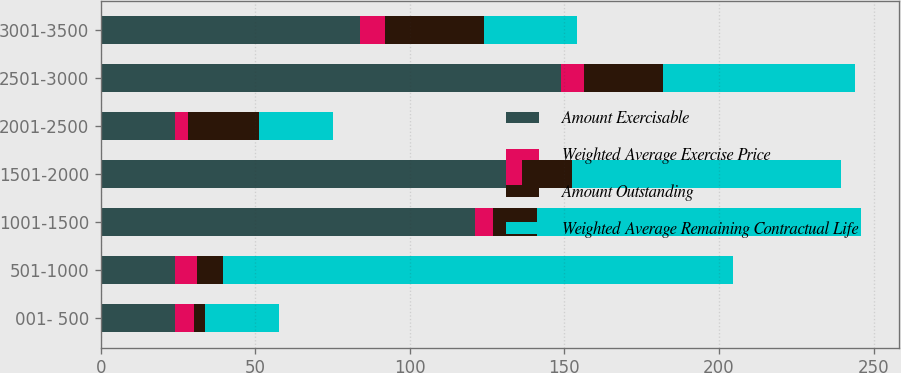Convert chart. <chart><loc_0><loc_0><loc_500><loc_500><stacked_bar_chart><ecel><fcel>001- 500<fcel>501-1000<fcel>1001-1500<fcel>1501-2000<fcel>2001-2500<fcel>2501-3000<fcel>3001-3500<nl><fcel>Amount Exercisable<fcel>24<fcel>24<fcel>121<fcel>131<fcel>24<fcel>149<fcel>84<nl><fcel>Weighted Average Exercise Price<fcel>6.2<fcel>7.2<fcel>6<fcel>5.3<fcel>4.3<fcel>7.2<fcel>8<nl><fcel>Amount Outstanding<fcel>3.38<fcel>8.37<fcel>14.09<fcel>16.14<fcel>22.97<fcel>25.85<fcel>31.96<nl><fcel>Weighted Average Remaining Contractual Life<fcel>24<fcel>165<fcel>105<fcel>87<fcel>24<fcel>62<fcel>30<nl></chart> 